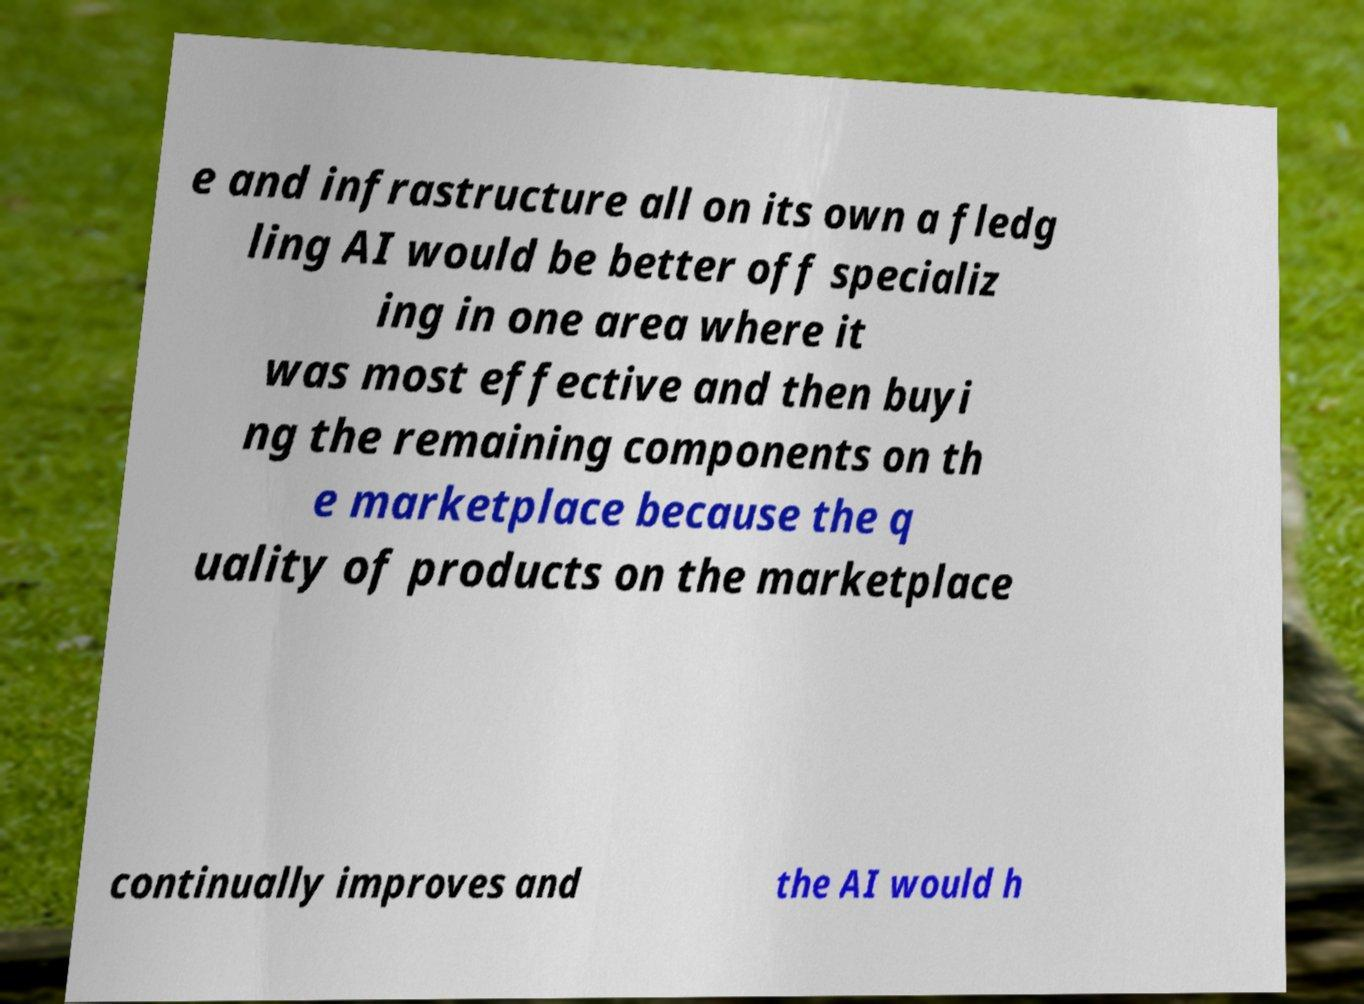What messages or text are displayed in this image? I need them in a readable, typed format. e and infrastructure all on its own a fledg ling AI would be better off specializ ing in one area where it was most effective and then buyi ng the remaining components on th e marketplace because the q uality of products on the marketplace continually improves and the AI would h 